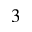<formula> <loc_0><loc_0><loc_500><loc_500>^ { 3 }</formula> 